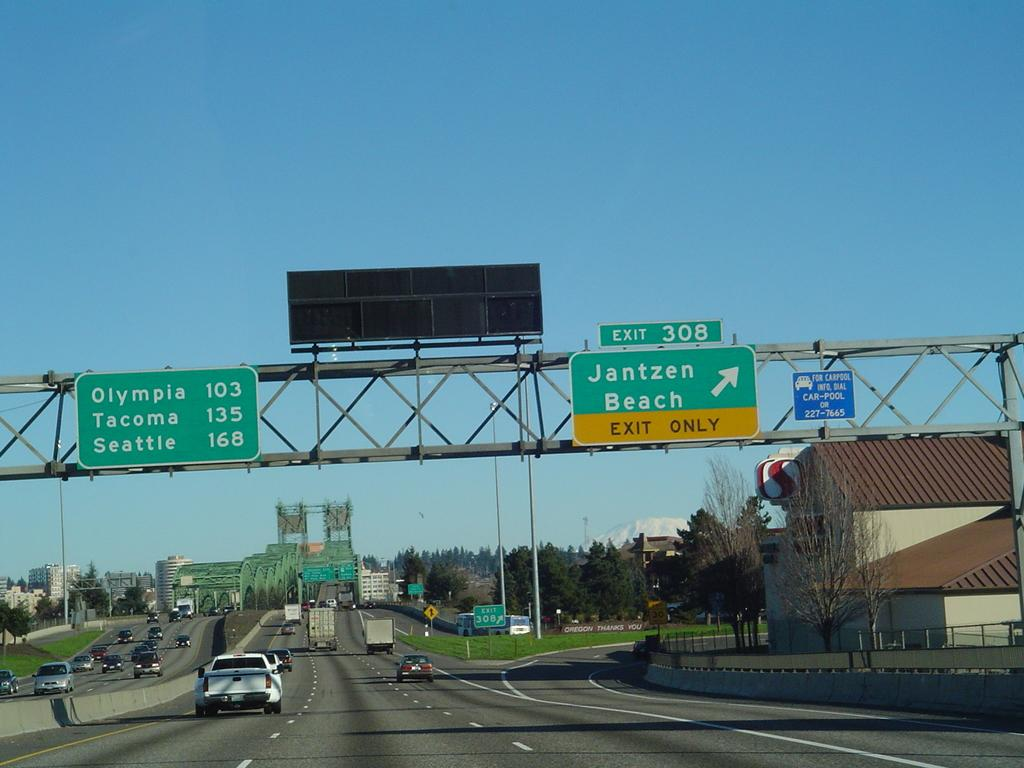<image>
Provide a brief description of the given image. a jantzen beach sign that is pointing to the right 